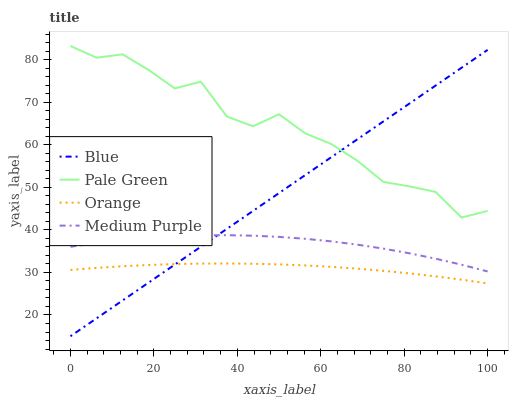Does Orange have the minimum area under the curve?
Answer yes or no. Yes. Does Pale Green have the maximum area under the curve?
Answer yes or no. Yes. Does Medium Purple have the minimum area under the curve?
Answer yes or no. No. Does Medium Purple have the maximum area under the curve?
Answer yes or no. No. Is Blue the smoothest?
Answer yes or no. Yes. Is Pale Green the roughest?
Answer yes or no. Yes. Is Orange the smoothest?
Answer yes or no. No. Is Orange the roughest?
Answer yes or no. No. Does Blue have the lowest value?
Answer yes or no. Yes. Does Orange have the lowest value?
Answer yes or no. No. Does Pale Green have the highest value?
Answer yes or no. Yes. Does Medium Purple have the highest value?
Answer yes or no. No. Is Orange less than Medium Purple?
Answer yes or no. Yes. Is Pale Green greater than Medium Purple?
Answer yes or no. Yes. Does Blue intersect Medium Purple?
Answer yes or no. Yes. Is Blue less than Medium Purple?
Answer yes or no. No. Is Blue greater than Medium Purple?
Answer yes or no. No. Does Orange intersect Medium Purple?
Answer yes or no. No. 